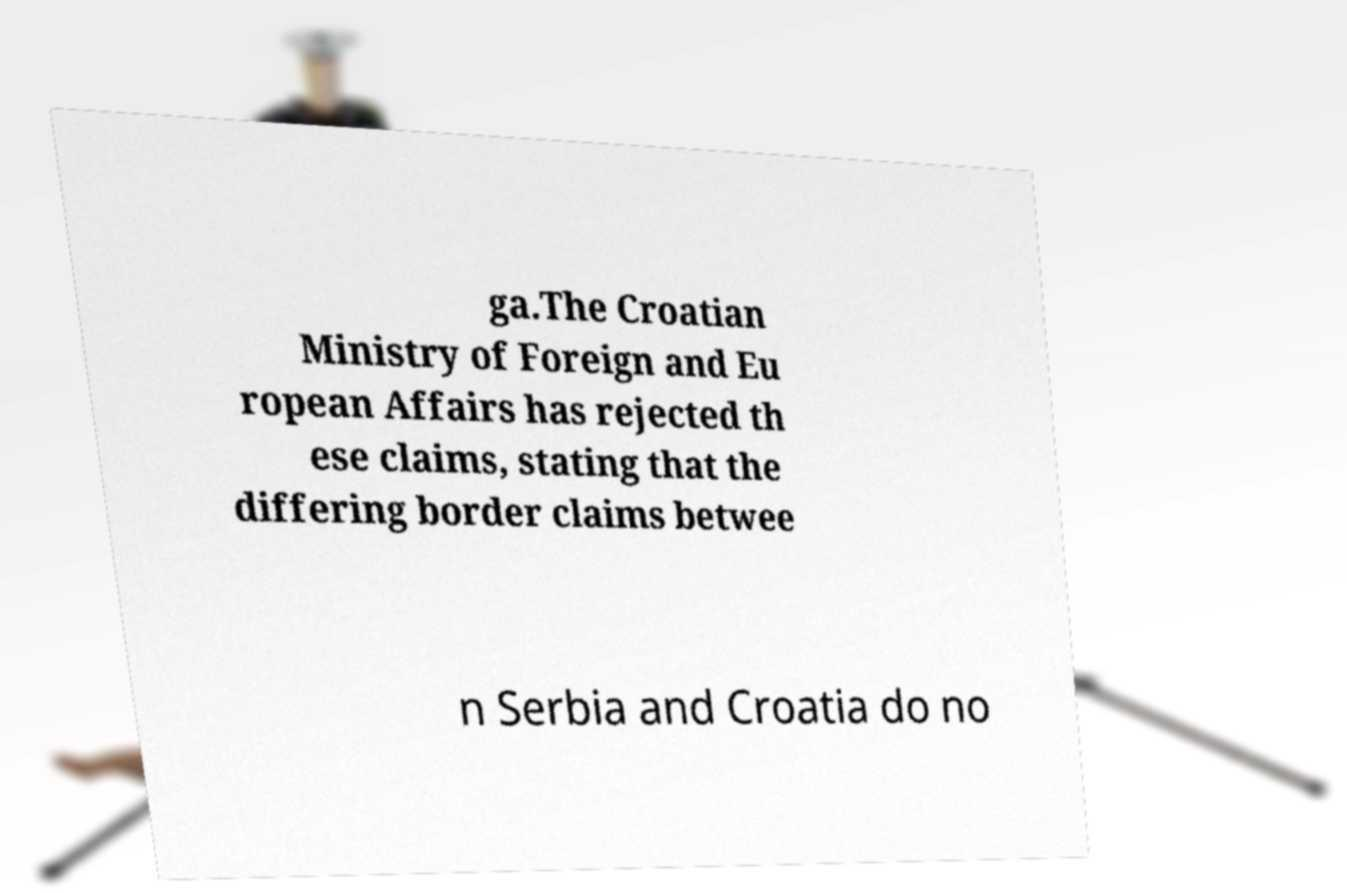What messages or text are displayed in this image? I need them in a readable, typed format. ga.The Croatian Ministry of Foreign and Eu ropean Affairs has rejected th ese claims, stating that the differing border claims betwee n Serbia and Croatia do no 